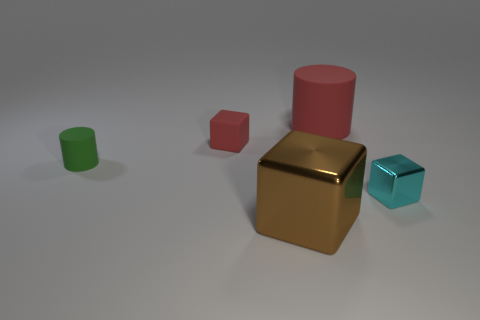Add 2 big blue shiny blocks. How many objects exist? 7 Subtract all cubes. How many objects are left? 2 Subtract all small blue blocks. Subtract all tiny blocks. How many objects are left? 3 Add 2 red matte blocks. How many red matte blocks are left? 3 Add 5 rubber cylinders. How many rubber cylinders exist? 7 Subtract 0 yellow cylinders. How many objects are left? 5 